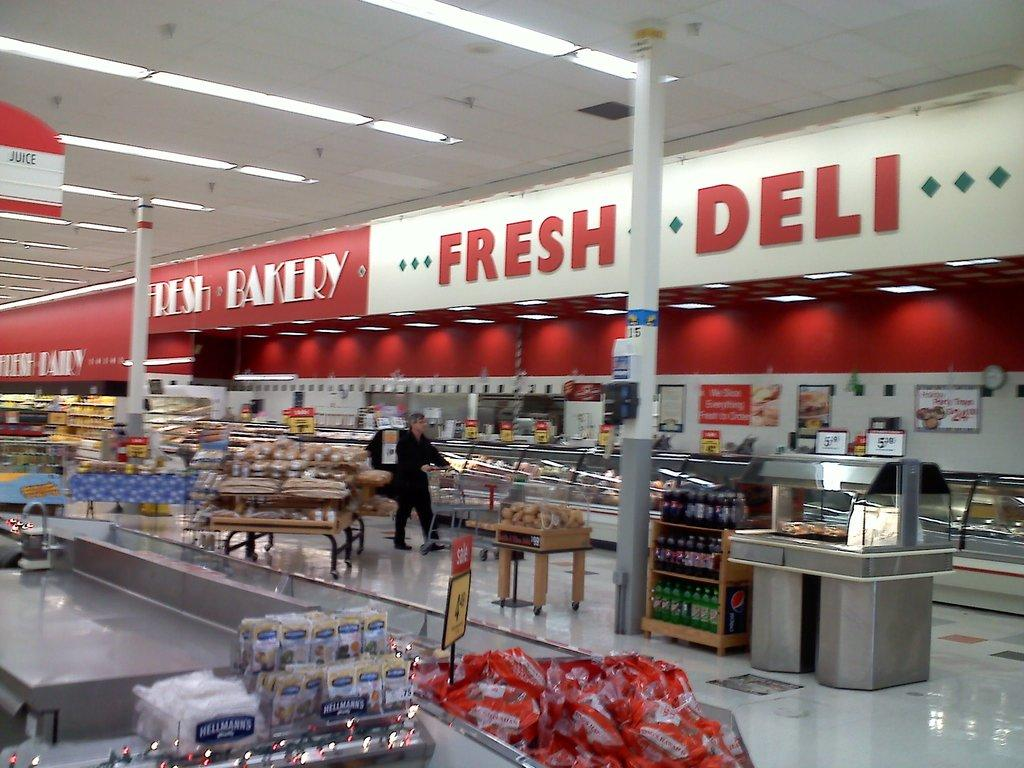<image>
Create a compact narrative representing the image presented. Person shopping in a supermarket under a sign saying Fresh Deli. 